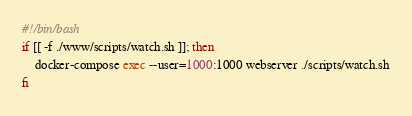<code> <loc_0><loc_0><loc_500><loc_500><_Bash_>#!/bin/bash
if [[ -f ./www/scripts/watch.sh ]]; then
    docker-compose exec --user=1000:1000 webserver ./scripts/watch.sh
fi
</code> 